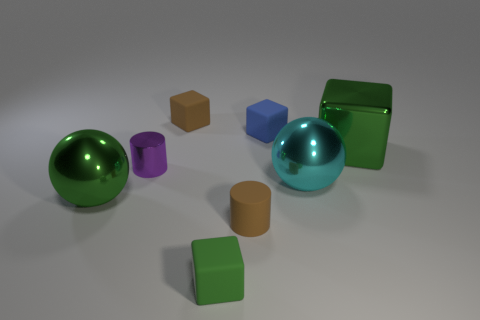Add 1 yellow rubber balls. How many objects exist? 9 Subtract all green cubes. How many purple cylinders are left? 1 Subtract all tiny objects. Subtract all small cubes. How many objects are left? 0 Add 1 small purple shiny objects. How many small purple shiny objects are left? 2 Add 6 tiny matte balls. How many tiny matte balls exist? 6 Subtract all blue cubes. How many cubes are left? 3 Subtract all tiny blue cubes. How many cubes are left? 3 Subtract 1 green balls. How many objects are left? 7 Subtract all cylinders. How many objects are left? 6 Subtract 2 cylinders. How many cylinders are left? 0 